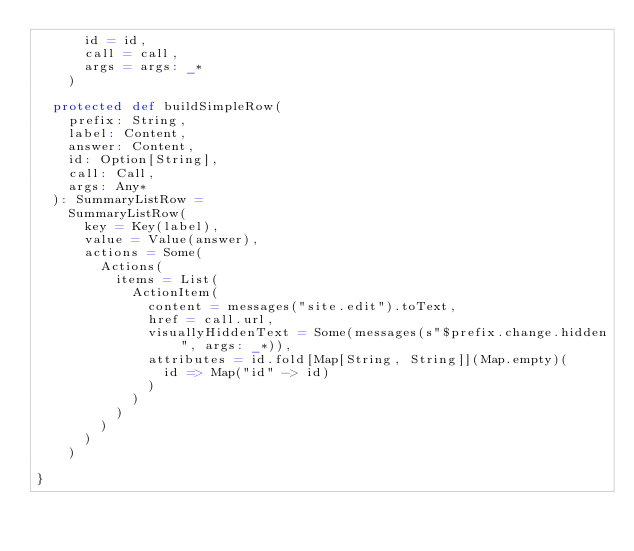Convert code to text. <code><loc_0><loc_0><loc_500><loc_500><_Scala_>      id = id,
      call = call,
      args = args: _*
    )

  protected def buildSimpleRow(
    prefix: String,
    label: Content,
    answer: Content,
    id: Option[String],
    call: Call,
    args: Any*
  ): SummaryListRow =
    SummaryListRow(
      key = Key(label),
      value = Value(answer),
      actions = Some(
        Actions(
          items = List(
            ActionItem(
              content = messages("site.edit").toText,
              href = call.url,
              visuallyHiddenText = Some(messages(s"$prefix.change.hidden", args: _*)),
              attributes = id.fold[Map[String, String]](Map.empty)(
                id => Map("id" -> id)
              )
            )
          )
        )
      )
    )

}
</code> 